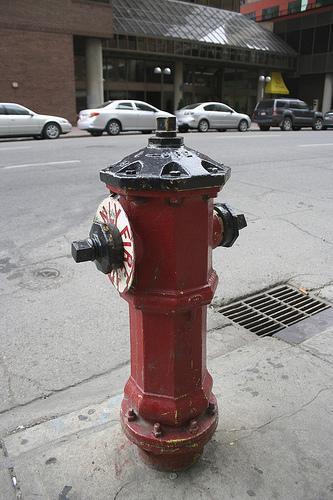How many cars are at least partially visible?
Give a very brief answer. 5. How many white cars are there?
Give a very brief answer. 3. 